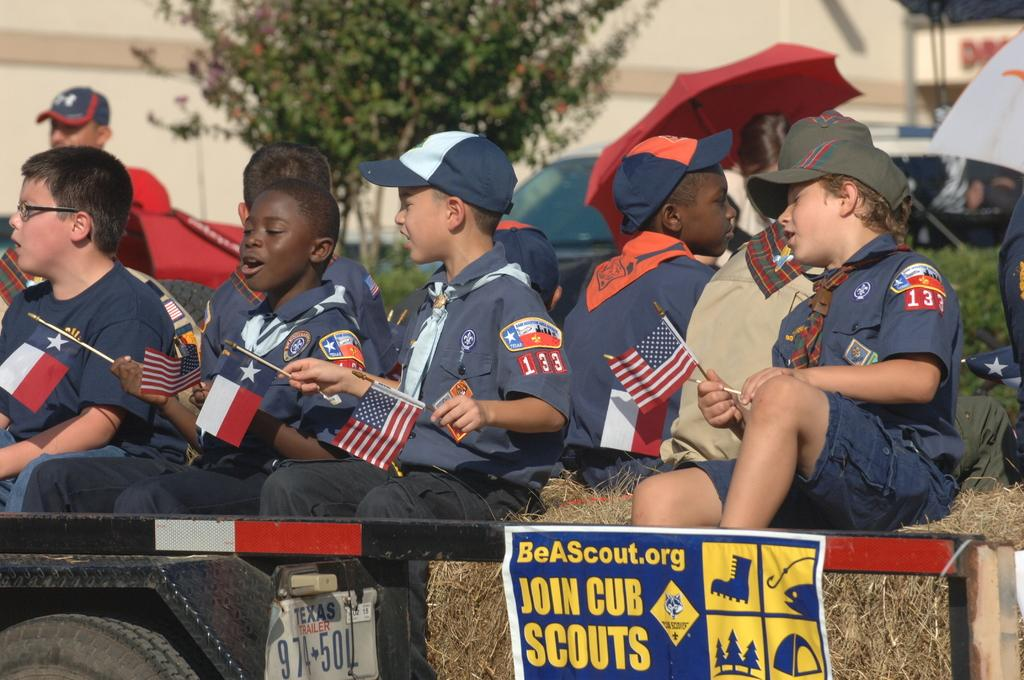What are the people in the image doing? There is a group of people sitting in the image. What are the people wearing? The people are wearing uniforms. What are the people holding in the image? The people are holding flags. What can be seen in the background of the image? There are vehicles, plants with green color, and a building with a cream color in the background. What type of bait is being used by the people in the image? There is no bait present in the image; the people are holding flags. Can you hear the thunder in the image? There is no sound or indication of thunder in the image. 